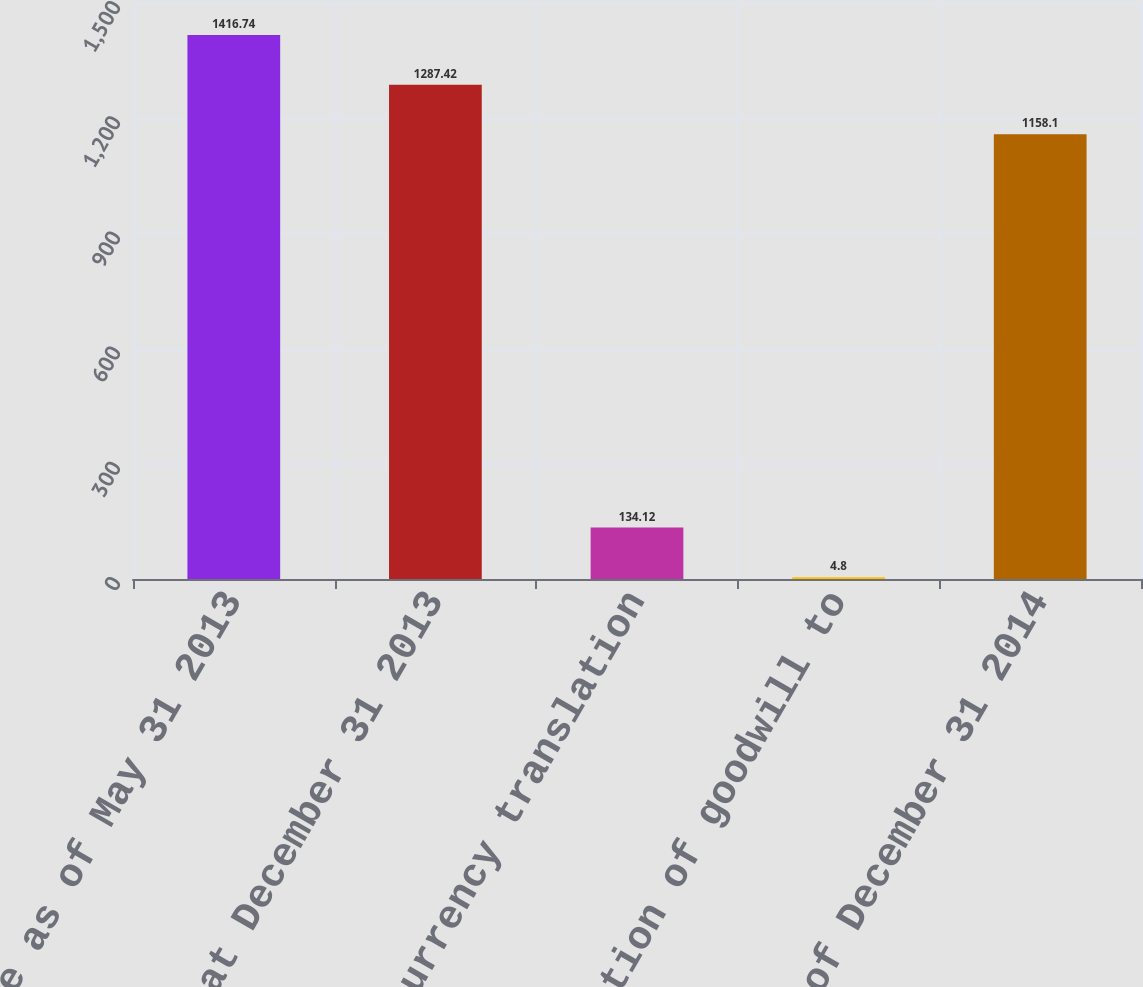Convert chart to OTSL. <chart><loc_0><loc_0><loc_500><loc_500><bar_chart><fcel>Balance as of May 31 2013<fcel>Balance at December 31 2013<fcel>Foreign currency translation<fcel>Reallocation of goodwill to<fcel>Balance as of December 31 2014<nl><fcel>1416.74<fcel>1287.42<fcel>134.12<fcel>4.8<fcel>1158.1<nl></chart> 